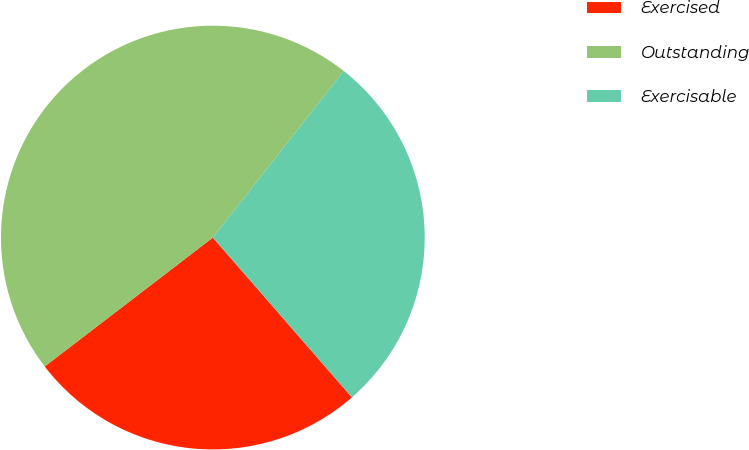Convert chart to OTSL. <chart><loc_0><loc_0><loc_500><loc_500><pie_chart><fcel>Exercised<fcel>Outstanding<fcel>Exercisable<nl><fcel>25.99%<fcel>46.01%<fcel>28.0%<nl></chart> 